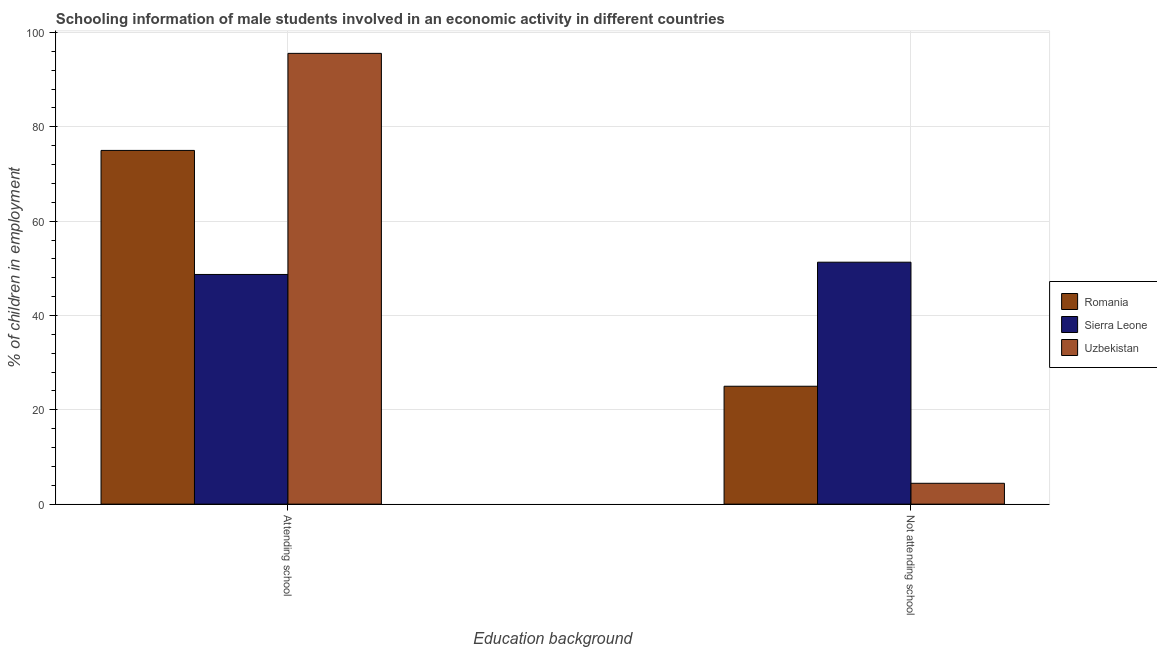How many different coloured bars are there?
Offer a very short reply. 3. How many groups of bars are there?
Make the answer very short. 2. How many bars are there on the 2nd tick from the right?
Your response must be concise. 3. What is the label of the 1st group of bars from the left?
Your answer should be very brief. Attending school. What is the percentage of employed males who are not attending school in Uzbekistan?
Ensure brevity in your answer.  4.42. Across all countries, what is the maximum percentage of employed males who are not attending school?
Provide a succinct answer. 51.3. Across all countries, what is the minimum percentage of employed males who are attending school?
Provide a short and direct response. 48.7. In which country was the percentage of employed males who are attending school maximum?
Offer a terse response. Uzbekistan. In which country was the percentage of employed males who are attending school minimum?
Provide a short and direct response. Sierra Leone. What is the total percentage of employed males who are attending school in the graph?
Your response must be concise. 219.28. What is the difference between the percentage of employed males who are not attending school in Sierra Leone and that in Romania?
Ensure brevity in your answer.  26.3. What is the difference between the percentage of employed males who are attending school in Romania and the percentage of employed males who are not attending school in Sierra Leone?
Your response must be concise. 23.7. What is the average percentage of employed males who are attending school per country?
Your answer should be very brief. 73.09. What is the difference between the percentage of employed males who are not attending school and percentage of employed males who are attending school in Uzbekistan?
Keep it short and to the point. -91.16. In how many countries, is the percentage of employed males who are not attending school greater than 32 %?
Offer a very short reply. 1. What is the ratio of the percentage of employed males who are attending school in Sierra Leone to that in Romania?
Offer a terse response. 0.65. What does the 1st bar from the left in Not attending school represents?
Offer a terse response. Romania. What does the 2nd bar from the right in Attending school represents?
Provide a short and direct response. Sierra Leone. What is the difference between two consecutive major ticks on the Y-axis?
Offer a terse response. 20. Where does the legend appear in the graph?
Give a very brief answer. Center right. How many legend labels are there?
Offer a terse response. 3. How are the legend labels stacked?
Your response must be concise. Vertical. What is the title of the graph?
Your answer should be compact. Schooling information of male students involved in an economic activity in different countries. What is the label or title of the X-axis?
Your response must be concise. Education background. What is the label or title of the Y-axis?
Offer a very short reply. % of children in employment. What is the % of children in employment in Sierra Leone in Attending school?
Keep it short and to the point. 48.7. What is the % of children in employment in Uzbekistan in Attending school?
Keep it short and to the point. 95.58. What is the % of children in employment of Sierra Leone in Not attending school?
Your answer should be compact. 51.3. What is the % of children in employment of Uzbekistan in Not attending school?
Provide a succinct answer. 4.42. Across all Education background, what is the maximum % of children in employment in Sierra Leone?
Keep it short and to the point. 51.3. Across all Education background, what is the maximum % of children in employment in Uzbekistan?
Your response must be concise. 95.58. Across all Education background, what is the minimum % of children in employment in Sierra Leone?
Keep it short and to the point. 48.7. Across all Education background, what is the minimum % of children in employment in Uzbekistan?
Offer a terse response. 4.42. What is the total % of children in employment in Romania in the graph?
Offer a terse response. 100. What is the total % of children in employment of Sierra Leone in the graph?
Your answer should be compact. 100. What is the total % of children in employment of Uzbekistan in the graph?
Ensure brevity in your answer.  100. What is the difference between the % of children in employment of Uzbekistan in Attending school and that in Not attending school?
Your answer should be compact. 91.16. What is the difference between the % of children in employment in Romania in Attending school and the % of children in employment in Sierra Leone in Not attending school?
Keep it short and to the point. 23.7. What is the difference between the % of children in employment of Romania in Attending school and the % of children in employment of Uzbekistan in Not attending school?
Your answer should be very brief. 70.58. What is the difference between the % of children in employment of Sierra Leone in Attending school and the % of children in employment of Uzbekistan in Not attending school?
Offer a terse response. 44.28. What is the average % of children in employment of Sierra Leone per Education background?
Make the answer very short. 50. What is the average % of children in employment in Uzbekistan per Education background?
Provide a short and direct response. 50. What is the difference between the % of children in employment of Romania and % of children in employment of Sierra Leone in Attending school?
Provide a succinct answer. 26.3. What is the difference between the % of children in employment of Romania and % of children in employment of Uzbekistan in Attending school?
Your answer should be very brief. -20.58. What is the difference between the % of children in employment in Sierra Leone and % of children in employment in Uzbekistan in Attending school?
Ensure brevity in your answer.  -46.88. What is the difference between the % of children in employment of Romania and % of children in employment of Sierra Leone in Not attending school?
Give a very brief answer. -26.3. What is the difference between the % of children in employment in Romania and % of children in employment in Uzbekistan in Not attending school?
Make the answer very short. 20.58. What is the difference between the % of children in employment of Sierra Leone and % of children in employment of Uzbekistan in Not attending school?
Your answer should be very brief. 46.88. What is the ratio of the % of children in employment of Sierra Leone in Attending school to that in Not attending school?
Your response must be concise. 0.95. What is the ratio of the % of children in employment in Uzbekistan in Attending school to that in Not attending school?
Provide a succinct answer. 21.61. What is the difference between the highest and the second highest % of children in employment in Uzbekistan?
Provide a succinct answer. 91.16. What is the difference between the highest and the lowest % of children in employment of Sierra Leone?
Offer a very short reply. 2.6. What is the difference between the highest and the lowest % of children in employment of Uzbekistan?
Your answer should be compact. 91.16. 